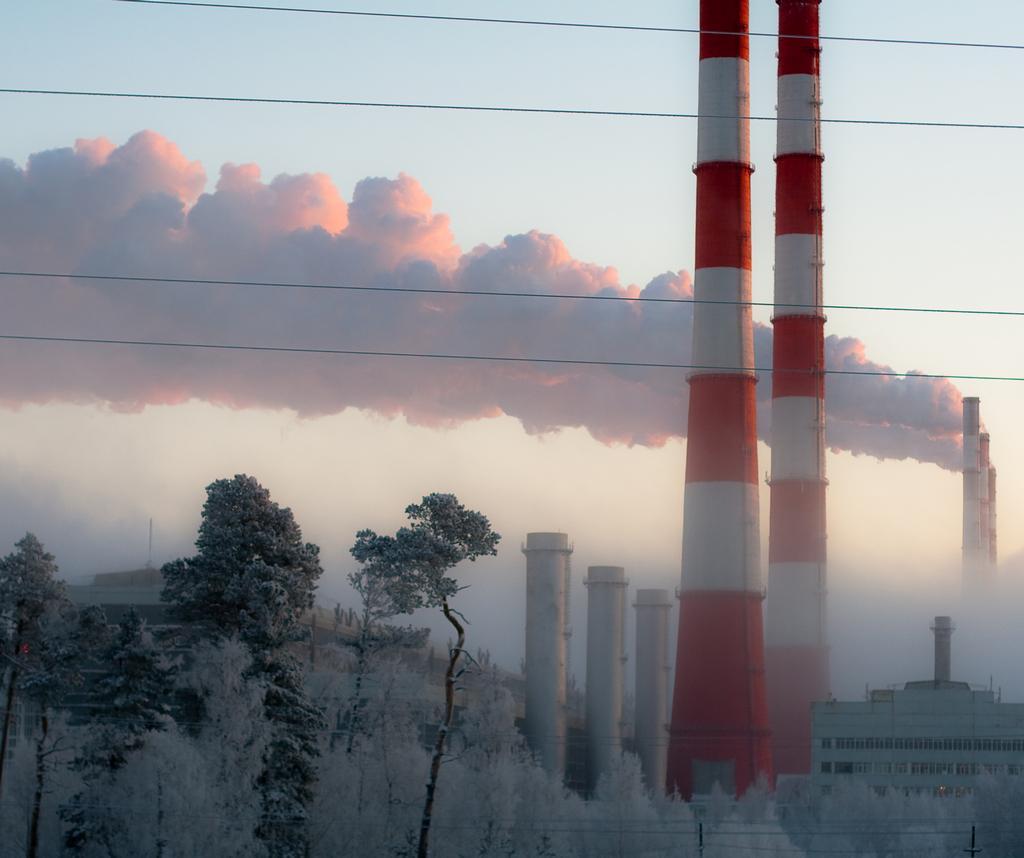In one or two sentences, can you explain what this image depicts? This image is taken outdoors. At the top of the image there is the sky with clouds. At the bottom of the image there are a few plants and trees. In the background there is a building. On the right side of the image there is a building with walls, windows and a roof. There is a pillar and there is a factory. There are a few smoke outlets. There is smoke and there are a few wires. 